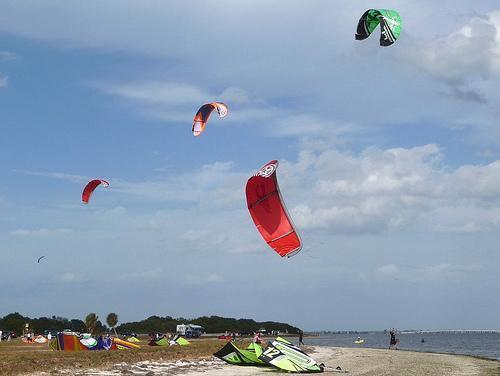How many parasails in the air?
Give a very brief answer. 5. 